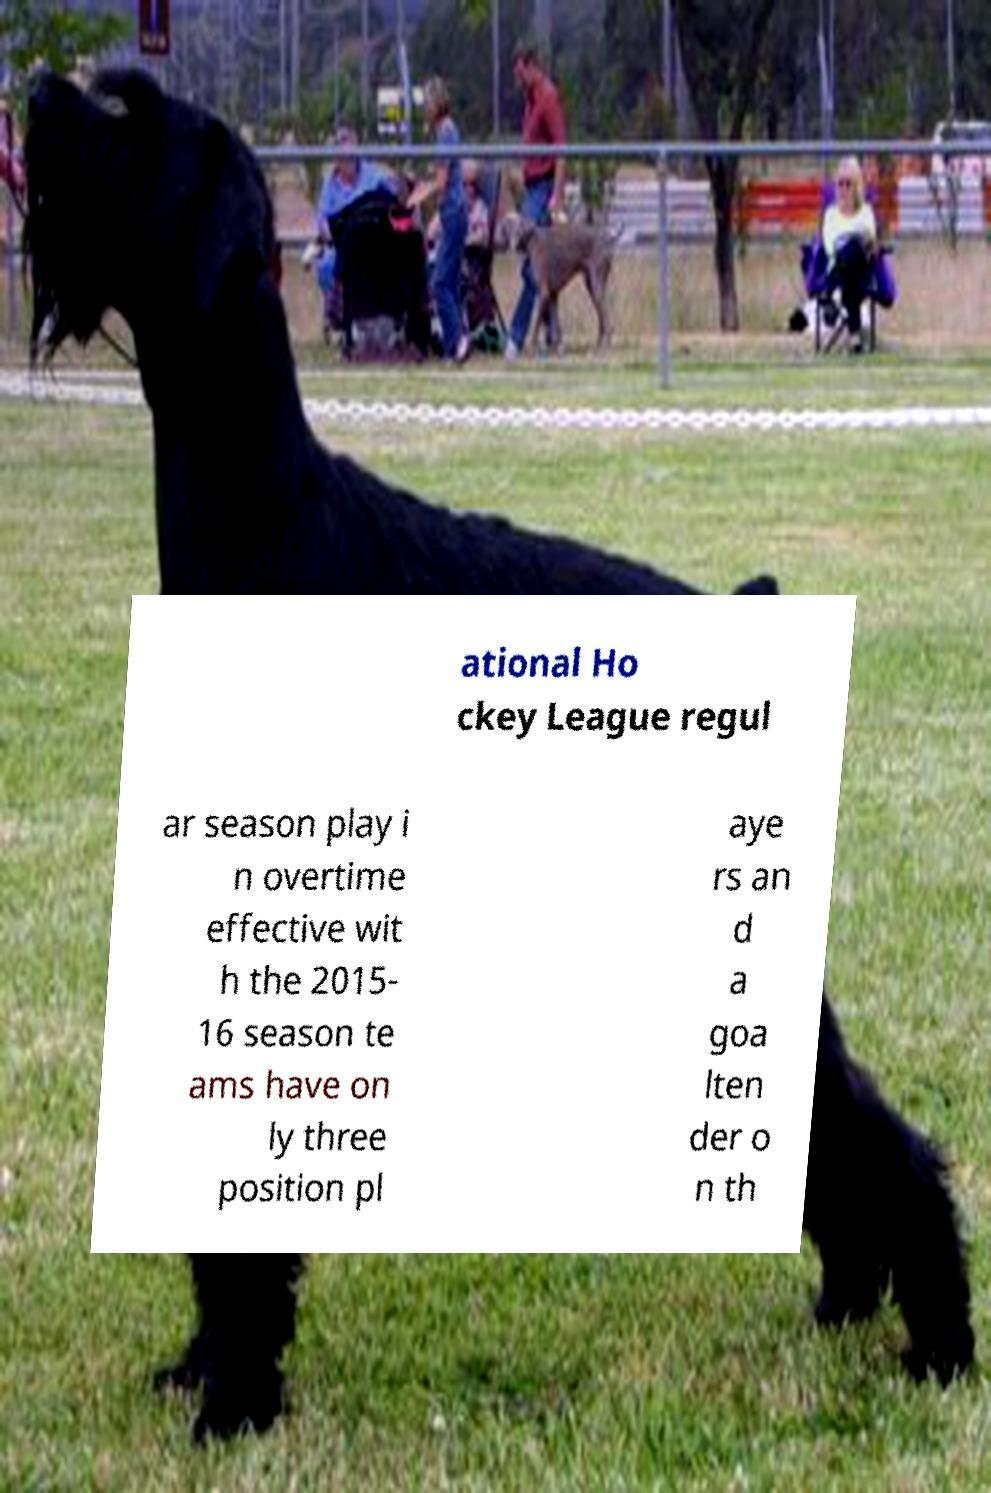Can you accurately transcribe the text from the provided image for me? ational Ho ckey League regul ar season play i n overtime effective wit h the 2015- 16 season te ams have on ly three position pl aye rs an d a goa lten der o n th 